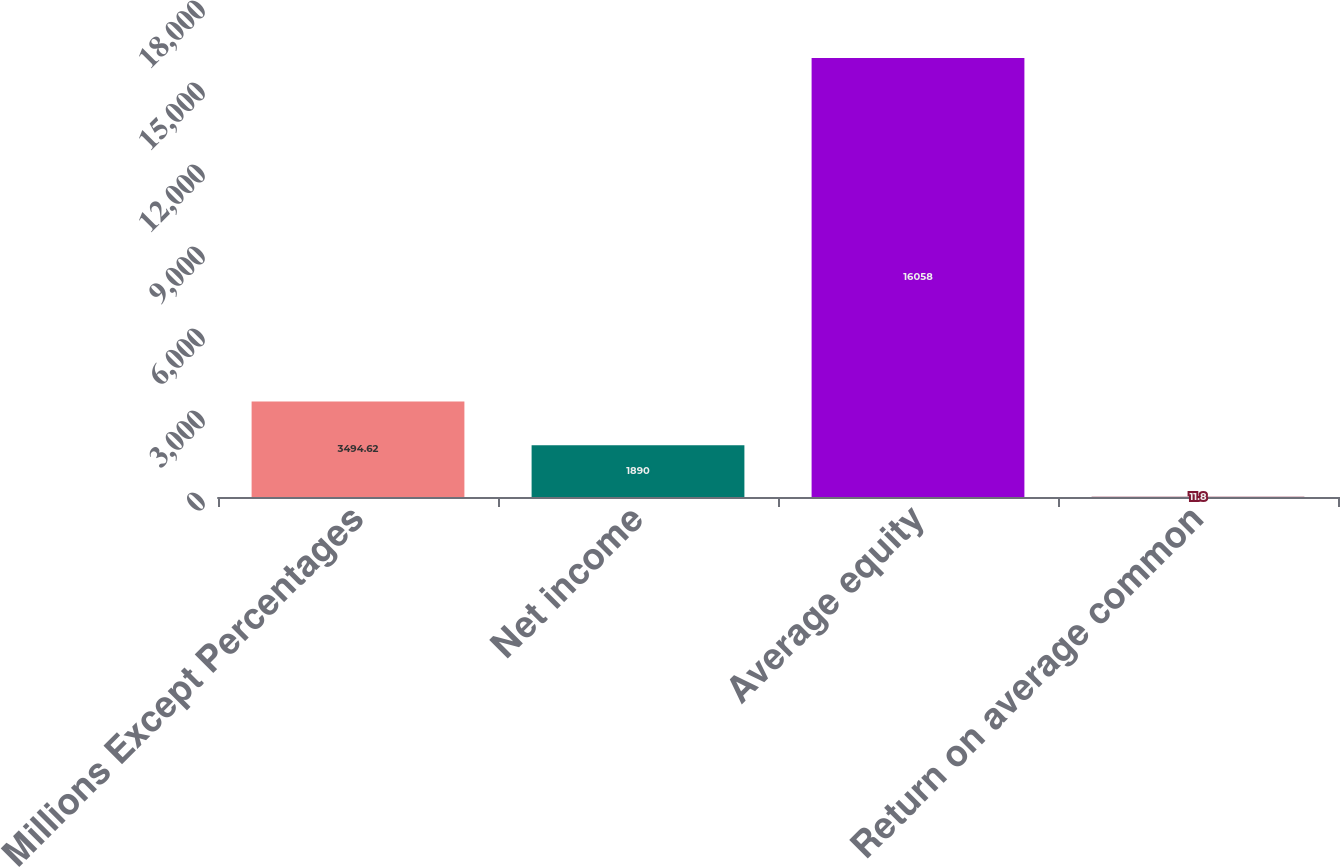Convert chart. <chart><loc_0><loc_0><loc_500><loc_500><bar_chart><fcel>Millions Except Percentages<fcel>Net income<fcel>Average equity<fcel>Return on average common<nl><fcel>3494.62<fcel>1890<fcel>16058<fcel>11.8<nl></chart> 